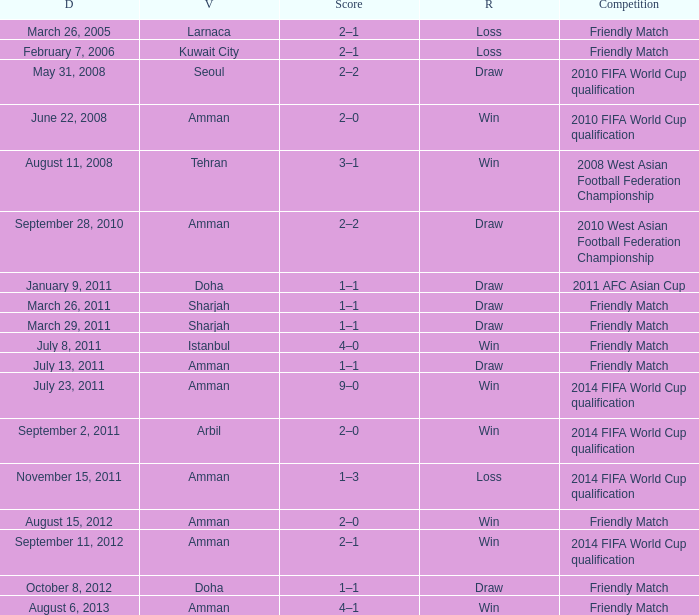What was the name of the competition that took place on may 31, 2008? 2010 FIFA World Cup qualification. 